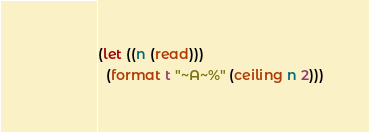Convert code to text. <code><loc_0><loc_0><loc_500><loc_500><_Lisp_>(let ((n (read)))
  (format t "~A~%" (ceiling n 2)))
</code> 